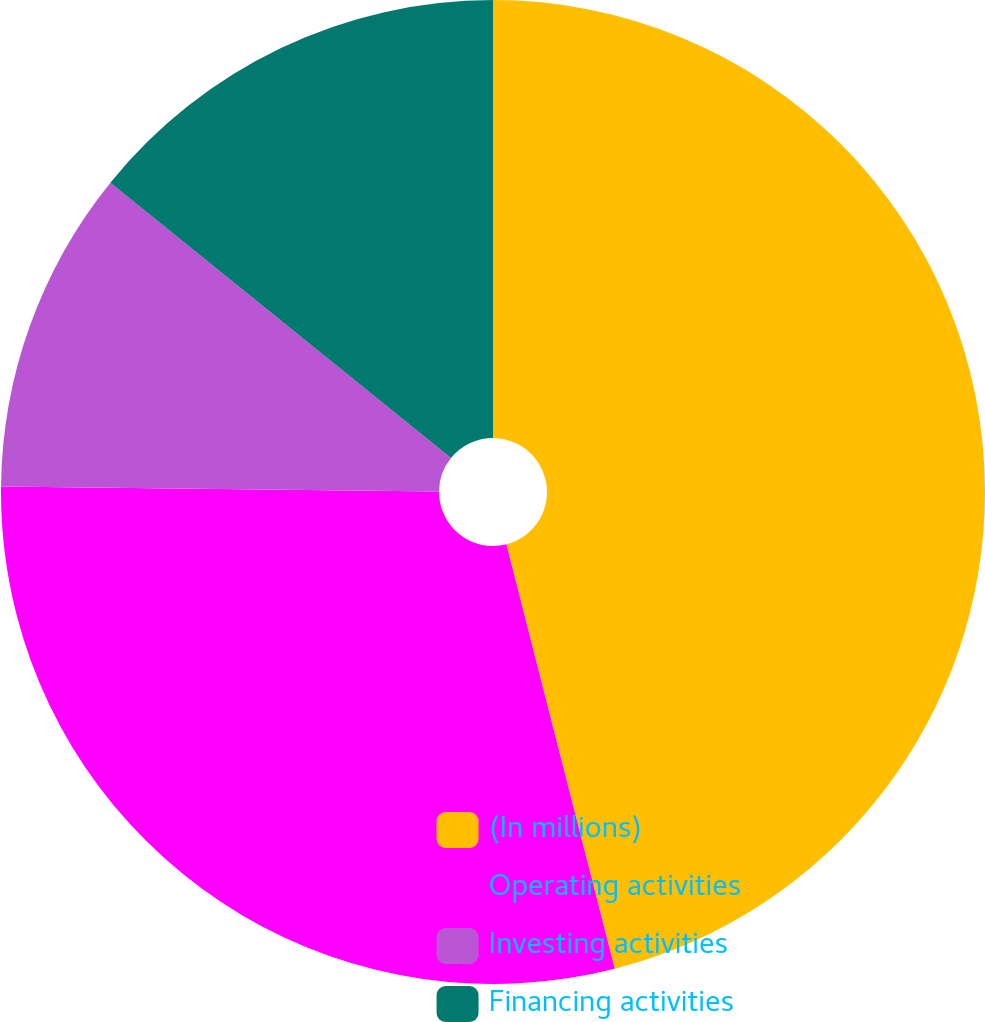Convert chart to OTSL. <chart><loc_0><loc_0><loc_500><loc_500><pie_chart><fcel>(In millions)<fcel>Operating activities<fcel>Investing activities<fcel>Financing activities<nl><fcel>46.02%<fcel>29.16%<fcel>10.64%<fcel>14.18%<nl></chart> 